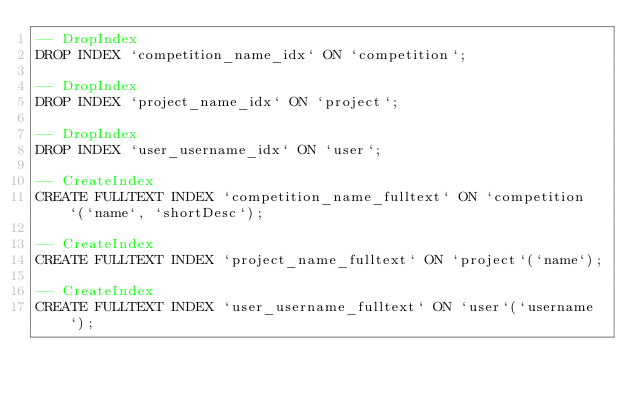Convert code to text. <code><loc_0><loc_0><loc_500><loc_500><_SQL_>-- DropIndex
DROP INDEX `competition_name_idx` ON `competition`;

-- DropIndex
DROP INDEX `project_name_idx` ON `project`;

-- DropIndex
DROP INDEX `user_username_idx` ON `user`;

-- CreateIndex
CREATE FULLTEXT INDEX `competition_name_fulltext` ON `competition`(`name`, `shortDesc`);

-- CreateIndex
CREATE FULLTEXT INDEX `project_name_fulltext` ON `project`(`name`);

-- CreateIndex
CREATE FULLTEXT INDEX `user_username_fulltext` ON `user`(`username`);
</code> 